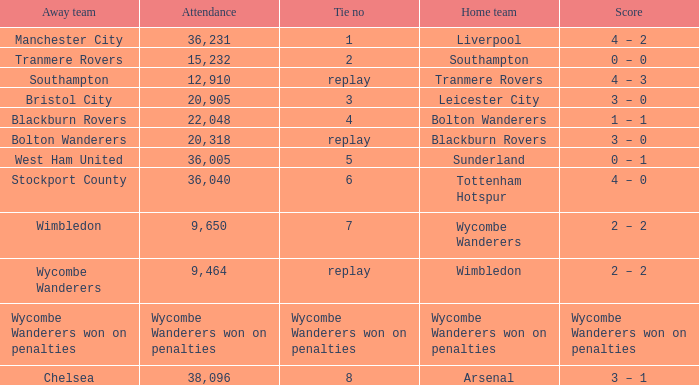What was the score for the game where the home team was Wycombe Wanderers? 2 – 2. 